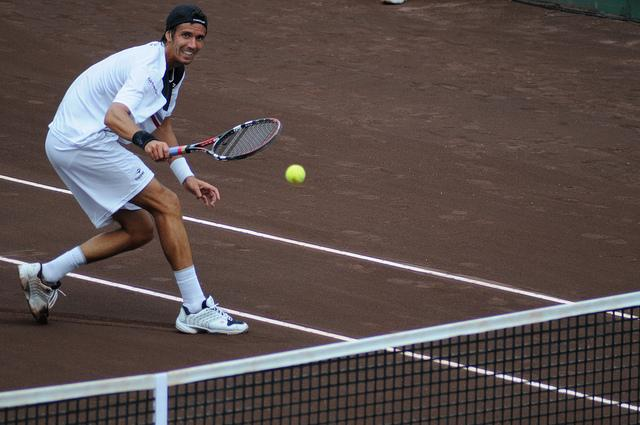How is the tennis player feeling?

Choices:
A) tired
B) angry
C) sad
D) happy happy 